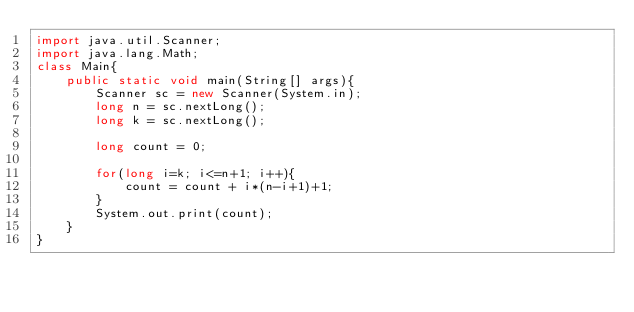<code> <loc_0><loc_0><loc_500><loc_500><_Java_>import java.util.Scanner;
import java.lang.Math;
class Main{
    public static void main(String[] args){
        Scanner sc = new Scanner(System.in);
        long n = sc.nextLong();
        long k = sc.nextLong();

        long count = 0;

        for(long i=k; i<=n+1; i++){
            count = count + i*(n-i+1)+1;
        }
        System.out.print(count);
    }
}</code> 